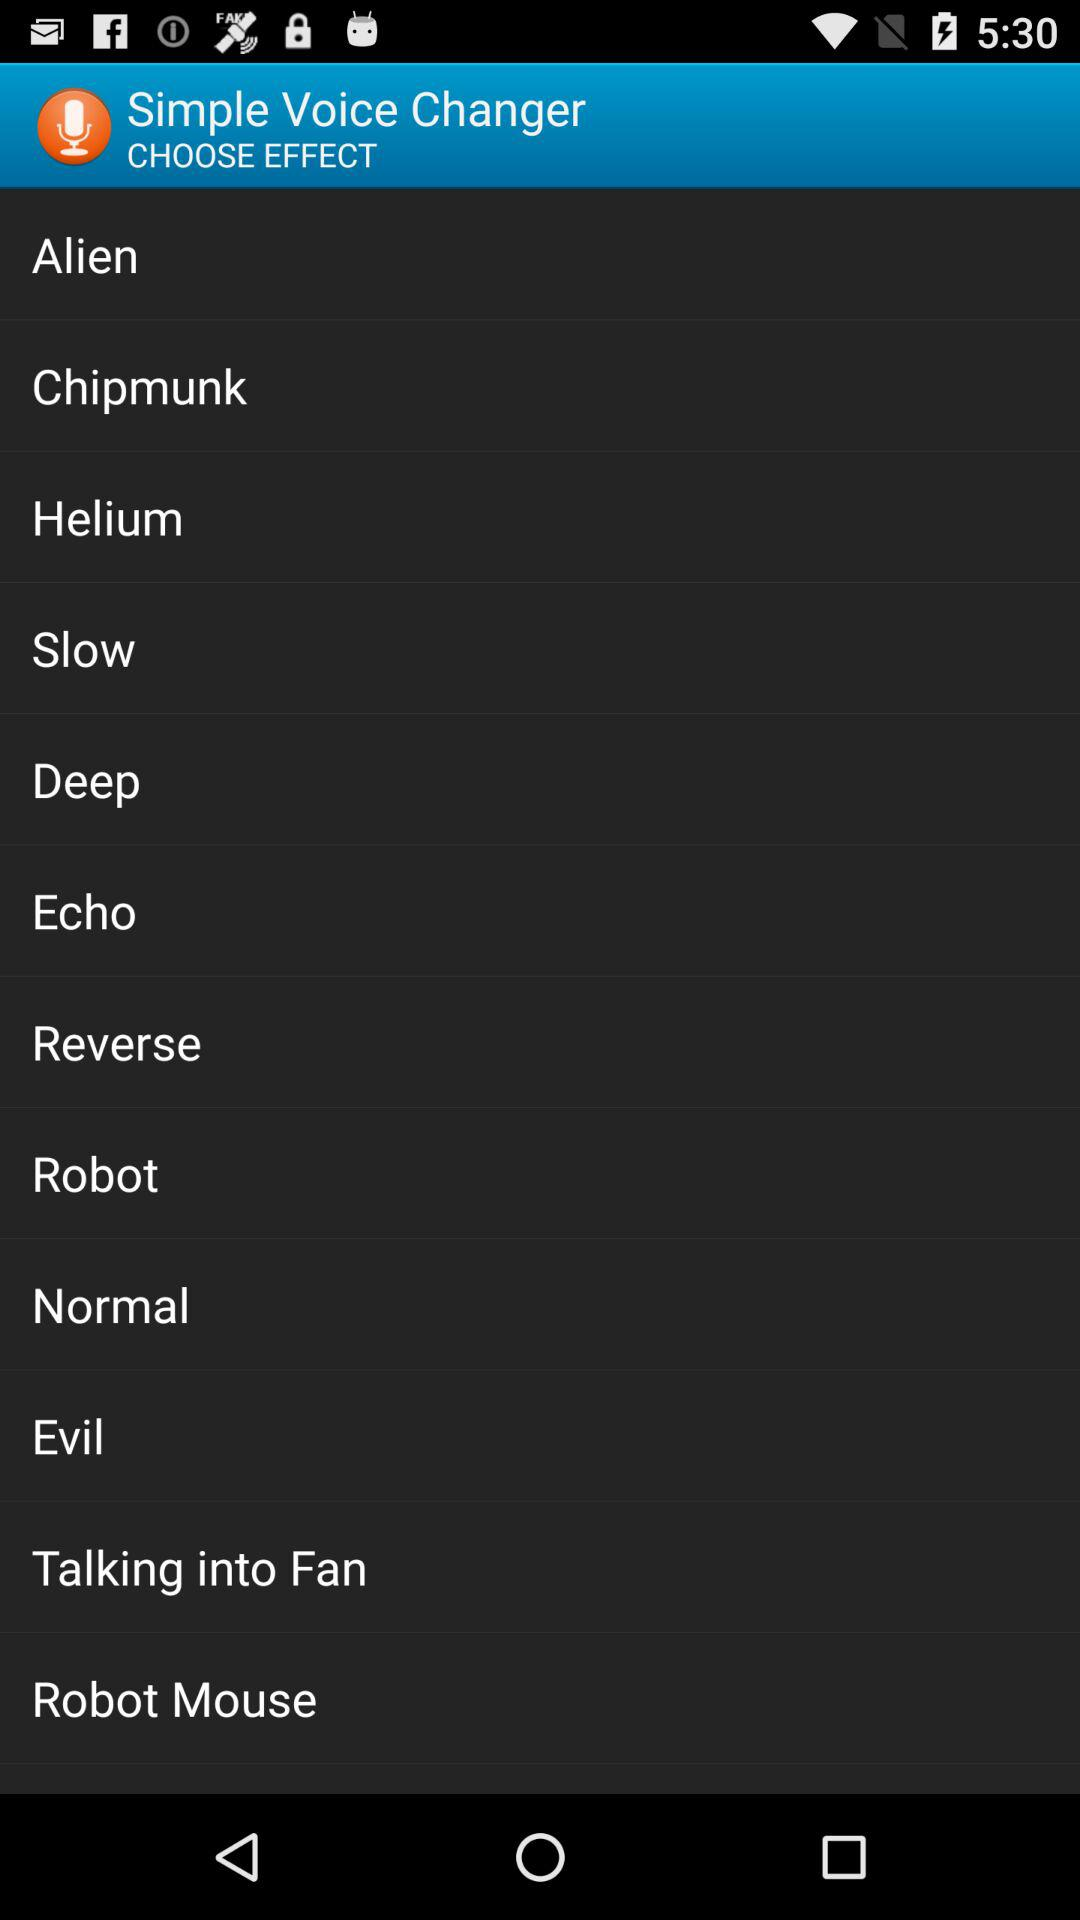How many effects are there to choose from?
Answer the question using a single word or phrase. 12 